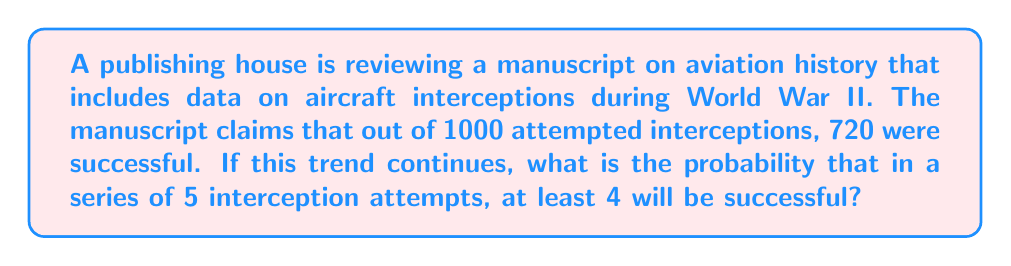Solve this math problem. Let's approach this step-by-step:

1) First, we need to determine the probability of a single successful interception:
   $p = \frac{720}{1000} = 0.72$

2) The probability of an unsuccessful interception is:
   $q = 1 - p = 1 - 0.72 = 0.28$

3) We want the probability of at least 4 successes out of 5 attempts. This can happen in two ways:
   - Exactly 4 successes and 1 failure
   - All 5 successes

4) We can use the binomial probability formula:
   $P(X = k) = \binom{n}{k} p^k q^{n-k}$

   Where:
   $n$ = number of trials (5)
   $k$ = number of successes
   $p$ = probability of success (0.72)
   $q$ = probability of failure (0.28)

5) Probability of exactly 4 successes:
   $P(X = 4) = \binom{5}{4} (0.72)^4 (0.28)^1$
   $= 5 \cdot (0.72)^4 \cdot 0.28$
   $= 5 \cdot 0.2687 \cdot 0.28$
   $= 0.3762$

6) Probability of all 5 successes:
   $P(X = 5) = \binom{5}{5} (0.72)^5 (0.28)^0$
   $= 1 \cdot (0.72)^5$
   $= 0.1934$

7) The probability of at least 4 successes is the sum of these two probabilities:
   $P(X \geq 4) = P(X = 4) + P(X = 5)$
   $= 0.3762 + 0.1934$
   $= 0.5696$

Therefore, the probability of at least 4 successful interceptions out of 5 attempts is approximately 0.5696 or 56.96%.
Answer: 0.5696 